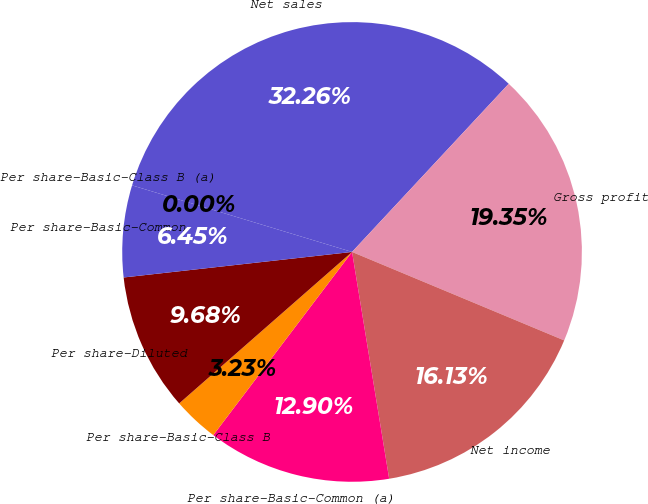Convert chart. <chart><loc_0><loc_0><loc_500><loc_500><pie_chart><fcel>Net sales<fcel>Gross profit<fcel>Net income<fcel>Per share-Basic-Common (a)<fcel>Per share-Basic-Class B<fcel>Per share-Diluted<fcel>Per share-Basic-Common<fcel>Per share-Basic-Class B (a)<nl><fcel>32.26%<fcel>19.35%<fcel>16.13%<fcel>12.9%<fcel>3.23%<fcel>9.68%<fcel>6.45%<fcel>0.0%<nl></chart> 